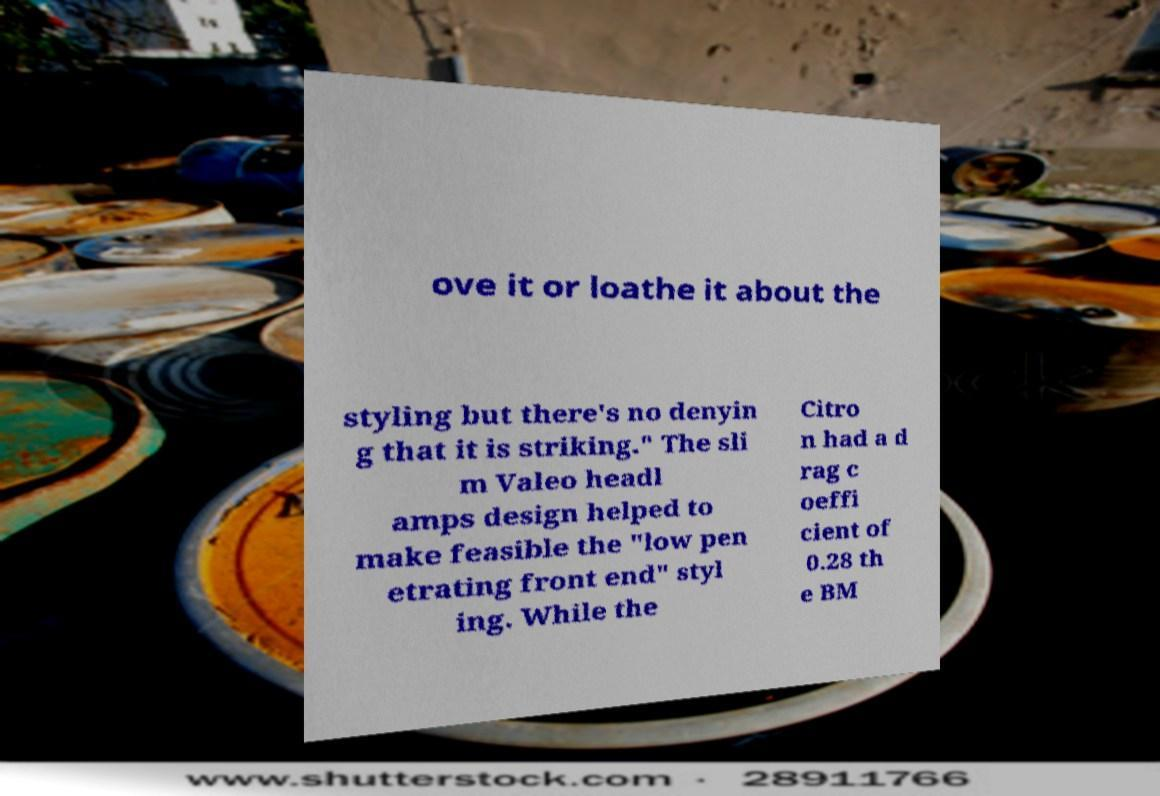There's text embedded in this image that I need extracted. Can you transcribe it verbatim? ove it or loathe it about the styling but there's no denyin g that it is striking." The sli m Valeo headl amps design helped to make feasible the "low pen etrating front end" styl ing. While the Citro n had a d rag c oeffi cient of 0.28 th e BM 